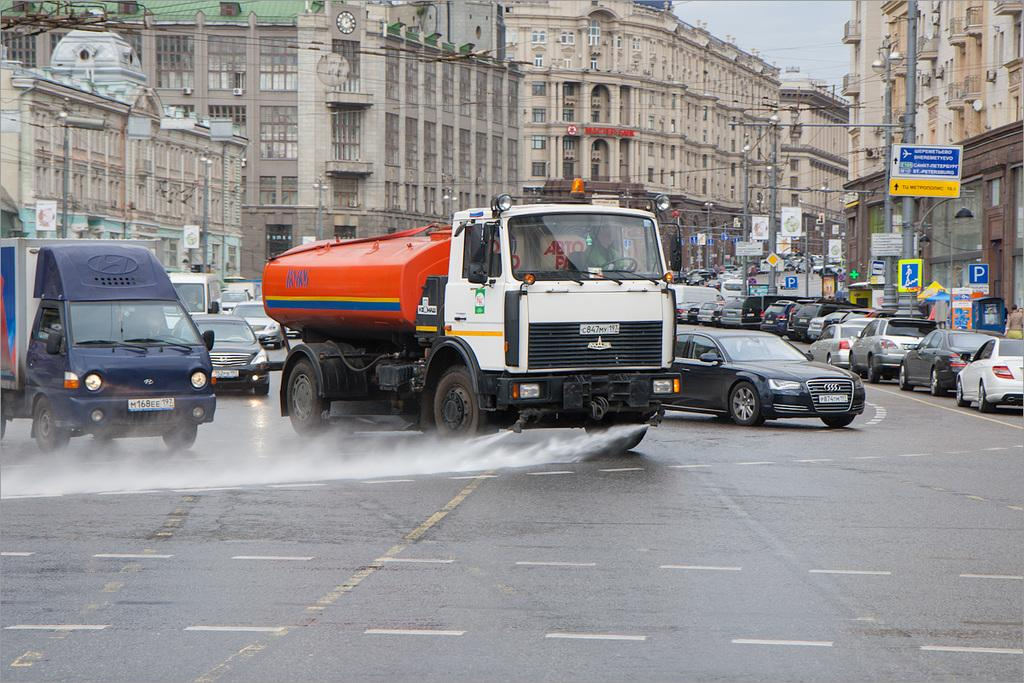What can be seen on the road in the image? There are many vehicles on the road in the image. What is visible in the background of the image? There are buildings in the background of the image. What are the characteristics of the buildings in the image? The buildings have walls, windows, pillars, and roofs. What else can be seen on the poles in the image? There are poles with sign boards and lamps in the image. How many numbers are visible on the vehicles in the image? There is no information about numbers on the vehicles in the image. Can you describe the drainage system in the image? There is no mention of a drainage system in the image. 